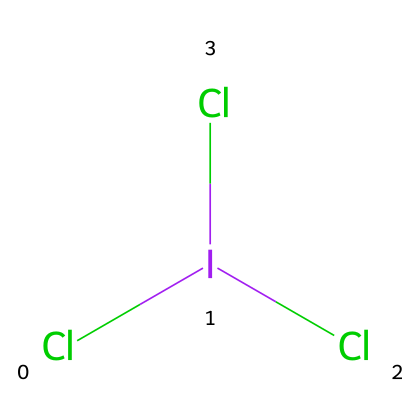What is the chemical name of this compound? The SMILES representation indicates the presence of iodine and chlorine atoms arranged in a trichloride formation, specifically denoted as iodine trichloride.
Answer: iodine trichloride How many chlorine atoms are present in this compound? By analyzing the SMILES notation, "Cl[I](Cl)Cl," there are three chlorine atoms attached to the iodine atom.
Answer: three Is iodine trichloride a hypervalent compound? Given that iodine is bonded to more than four atoms (three chlorine atoms) in its highest oxidation state, this confirms that it is considered a hypervalent compound.
Answer: yes What is the central atom in this structure? In the notation, iodine is indicated at the center of the structure as it is bonded to multiple chlorine atoms, thus making it the central atom.
Answer: iodine How many total atoms are in this compound? Counting the atoms from the SMILES notation, there is one iodine and three chlorine atoms, resulting in a total of four atoms.
Answer: four What oxidation state is iodine in this compound? Iodine in iodine trichloride has the oxidation state of +3, as it is bonded to three highly electronegative chlorine atoms which contribute an overall negative charge.
Answer: +3 